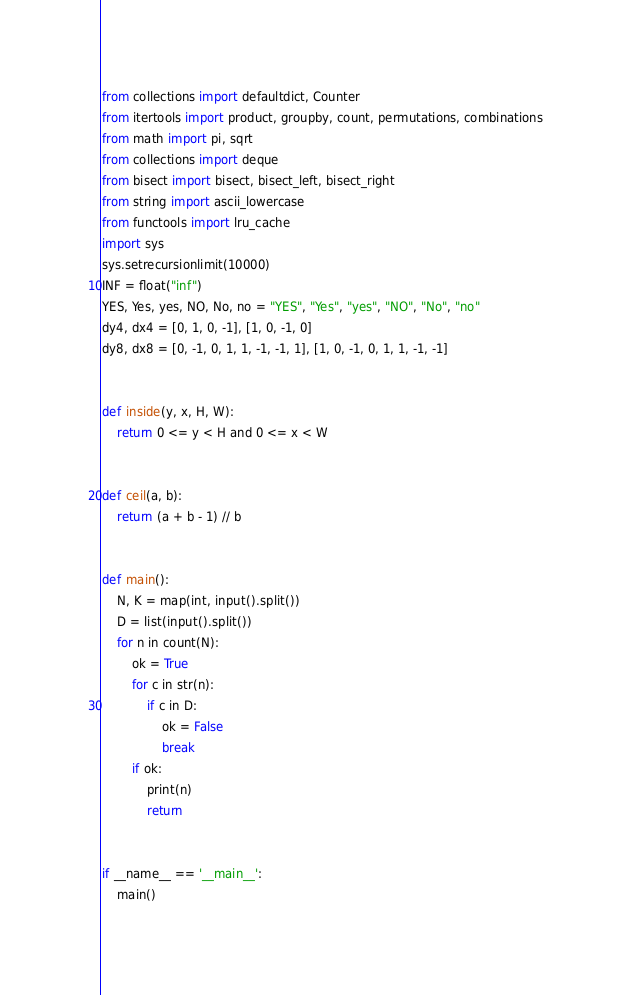<code> <loc_0><loc_0><loc_500><loc_500><_Python_>from collections import defaultdict, Counter
from itertools import product, groupby, count, permutations, combinations
from math import pi, sqrt
from collections import deque
from bisect import bisect, bisect_left, bisect_right
from string import ascii_lowercase
from functools import lru_cache
import sys
sys.setrecursionlimit(10000)
INF = float("inf")
YES, Yes, yes, NO, No, no = "YES", "Yes", "yes", "NO", "No", "no"
dy4, dx4 = [0, 1, 0, -1], [1, 0, -1, 0]
dy8, dx8 = [0, -1, 0, 1, 1, -1, -1, 1], [1, 0, -1, 0, 1, 1, -1, -1]


def inside(y, x, H, W):
    return 0 <= y < H and 0 <= x < W


def ceil(a, b):
    return (a + b - 1) // b


def main():
    N, K = map(int, input().split())
    D = list(input().split())
    for n in count(N):
        ok = True
        for c in str(n):
            if c in D:
                ok = False
                break
        if ok:
            print(n)
            return


if __name__ == '__main__':
    main()
</code> 